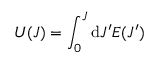Convert formula to latex. <formula><loc_0><loc_0><loc_500><loc_500>U ( J ) = \int _ { 0 } ^ { J } d J ^ { \prime } E ( J ^ { \prime } )</formula> 